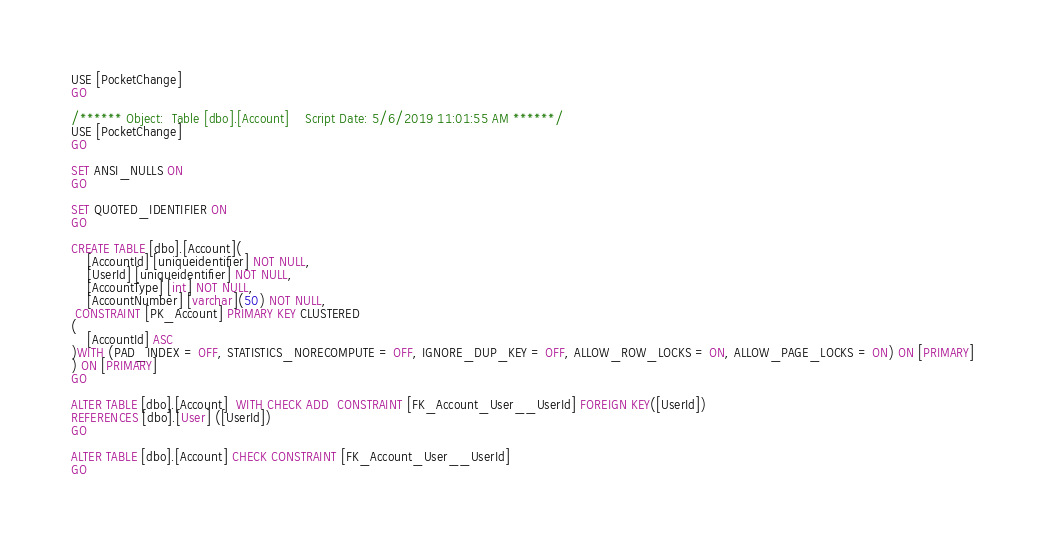Convert code to text. <code><loc_0><loc_0><loc_500><loc_500><_SQL_>USE [PocketChange]
GO

/****** Object:  Table [dbo].[Account]    Script Date: 5/6/2019 11:01:55 AM ******/
USE [PocketChange]
GO

SET ANSI_NULLS ON
GO

SET QUOTED_IDENTIFIER ON
GO

CREATE TABLE [dbo].[Account](
	[AccountId] [uniqueidentifier] NOT NULL,
	[UserId] [uniqueidentifier] NOT NULL,
	[AccountType] [int] NOT NULL,
	[AccountNumber] [varchar](50) NOT NULL,
 CONSTRAINT [PK_Account] PRIMARY KEY CLUSTERED 
(
	[AccountId] ASC
)WITH (PAD_INDEX = OFF, STATISTICS_NORECOMPUTE = OFF, IGNORE_DUP_KEY = OFF, ALLOW_ROW_LOCKS = ON, ALLOW_PAGE_LOCKS = ON) ON [PRIMARY]
) ON [PRIMARY]
GO

ALTER TABLE [dbo].[Account]  WITH CHECK ADD  CONSTRAINT [FK_Account_User__UserId] FOREIGN KEY([UserId])
REFERENCES [dbo].[User] ([UserId])
GO

ALTER TABLE [dbo].[Account] CHECK CONSTRAINT [FK_Account_User__UserId]
GO</code> 